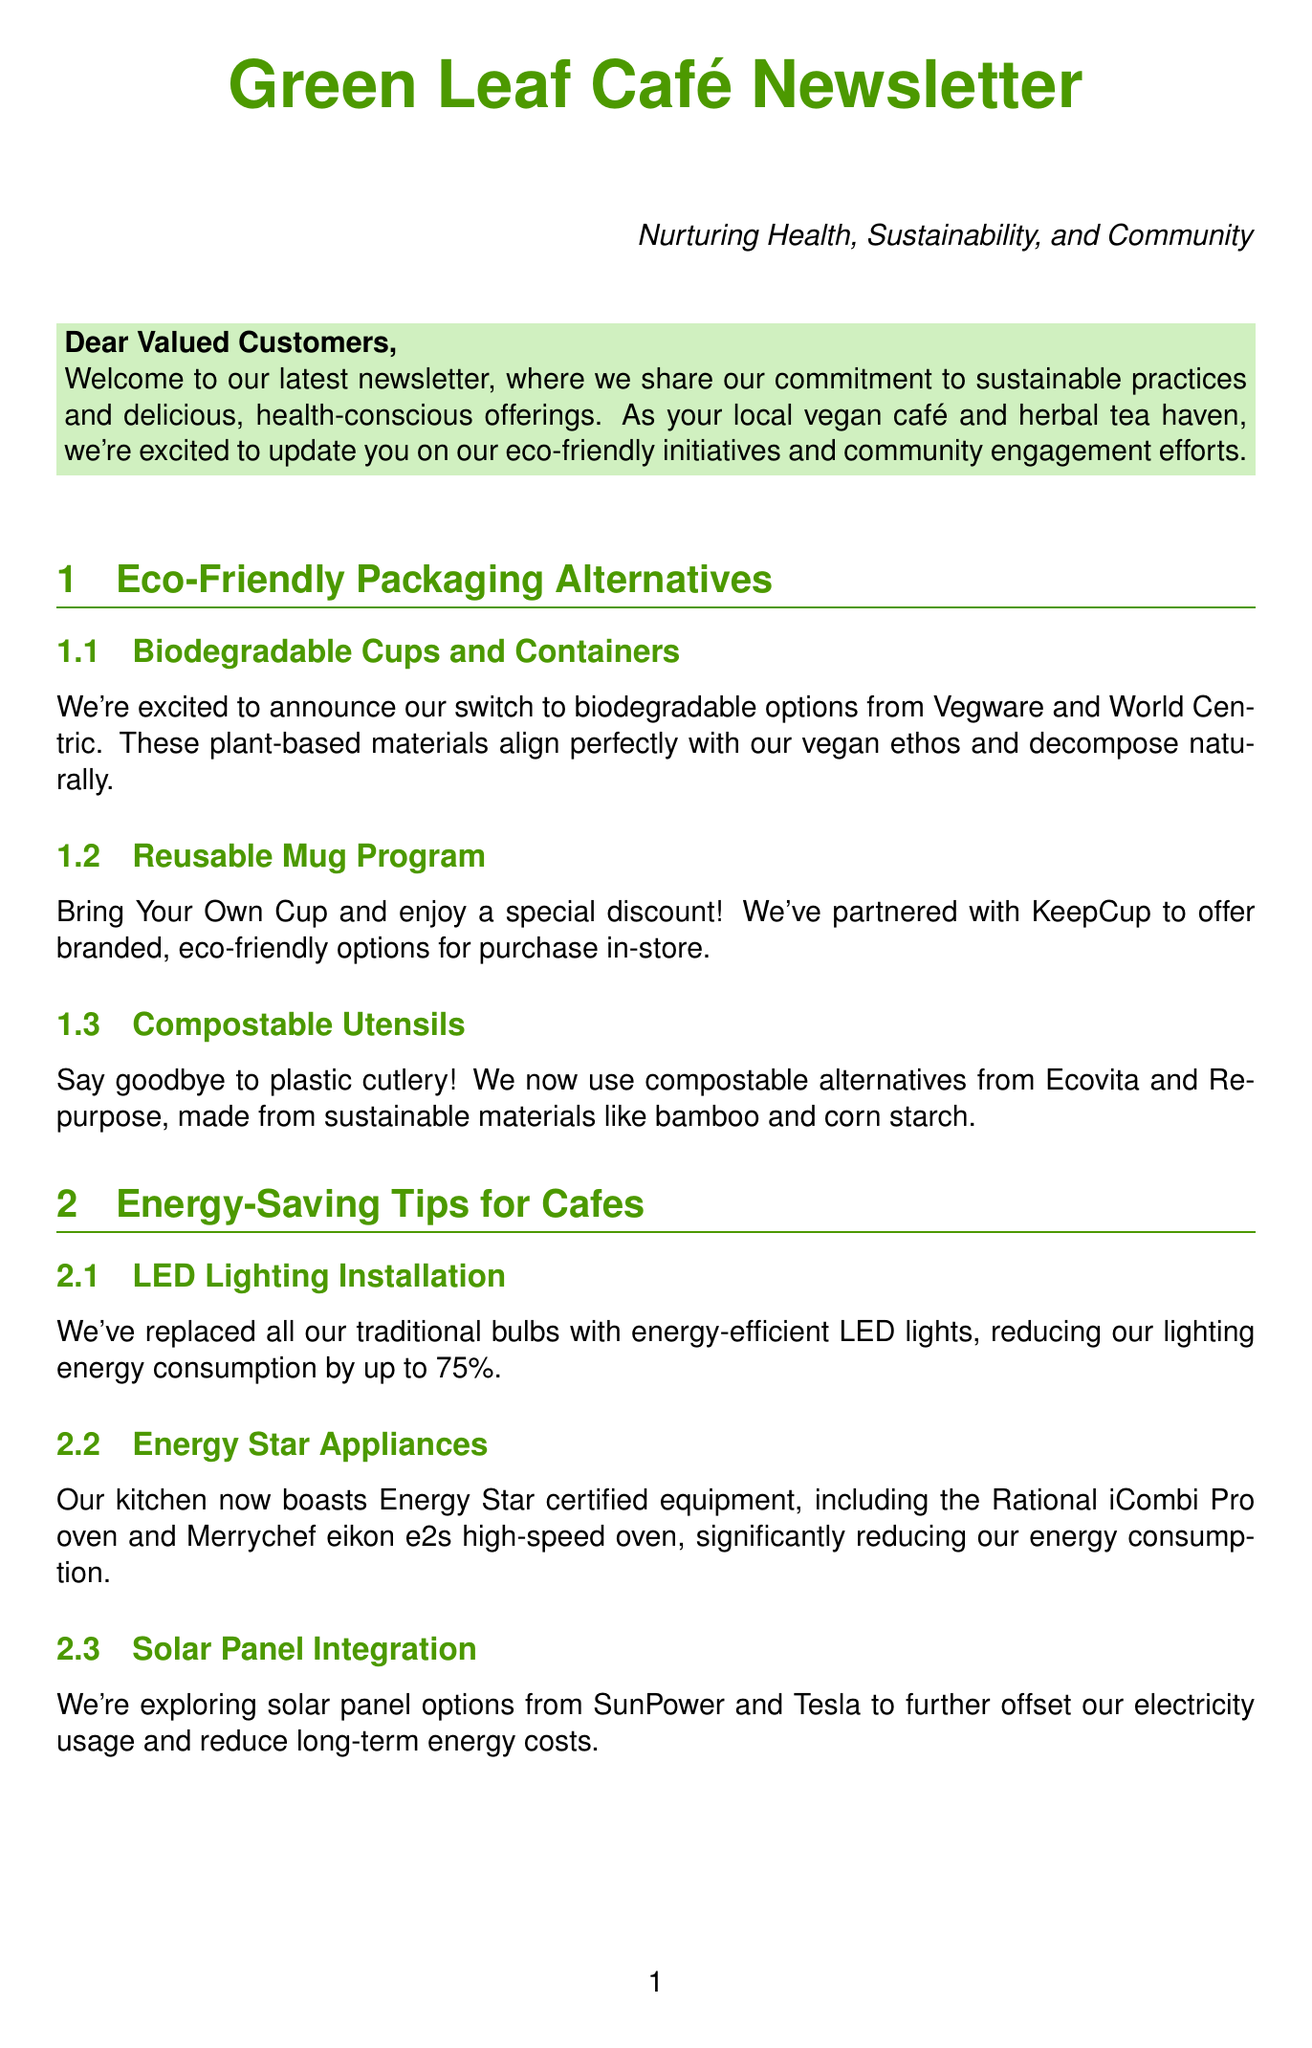what are the eco-friendly packaging options mentioned? The document lists biodegradable cups, reusable mugs, and compostable utensils as eco-friendly packaging options.
Answer: biodegradable cups, reusable mugs, compostable utensils how much can LED lighting reduce energy consumption? The document states that replacing traditional bulbs with LED lights can reduce lighting energy consumption by up to 75%.
Answer: up to 75% which companies are suggested for solar panel installation? The newsletter suggests SunPower and Tesla for solar panel installation options.
Answer: SunPower, Tesla what is the purpose of the composting program? The composting program is implemented to dispose of food scraps properly and support local gardens.
Answer: proper disposal, support local gardens how can customers earn rewards in the loyalty program? Customers can earn rewards by making sustainable choices like using reusable containers or participating in the composting program.
Answer: sustainable choices, composting program how often are the sustainability workshops held? The newsletter mentions that the sustainability workshops are held monthly.
Answer: monthly which brand offers Fair Trade certified tea options? The document mentions Traditional Medicinals and Numi Organic Tea as brands offering Fair Trade certified tea.
Answer: Traditional Medicinals, Numi Organic Tea what are two suggested brands for compostable utensils? The document lists Ecovita and Repurpose as brands for compostable utensils.
Answer: Ecovita, Repurpose 